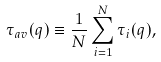Convert formula to latex. <formula><loc_0><loc_0><loc_500><loc_500>\tau _ { a v } ( q ) \equiv \frac { 1 } { N } \sum _ { i = 1 } ^ { N } \tau _ { i } ( q ) ,</formula> 